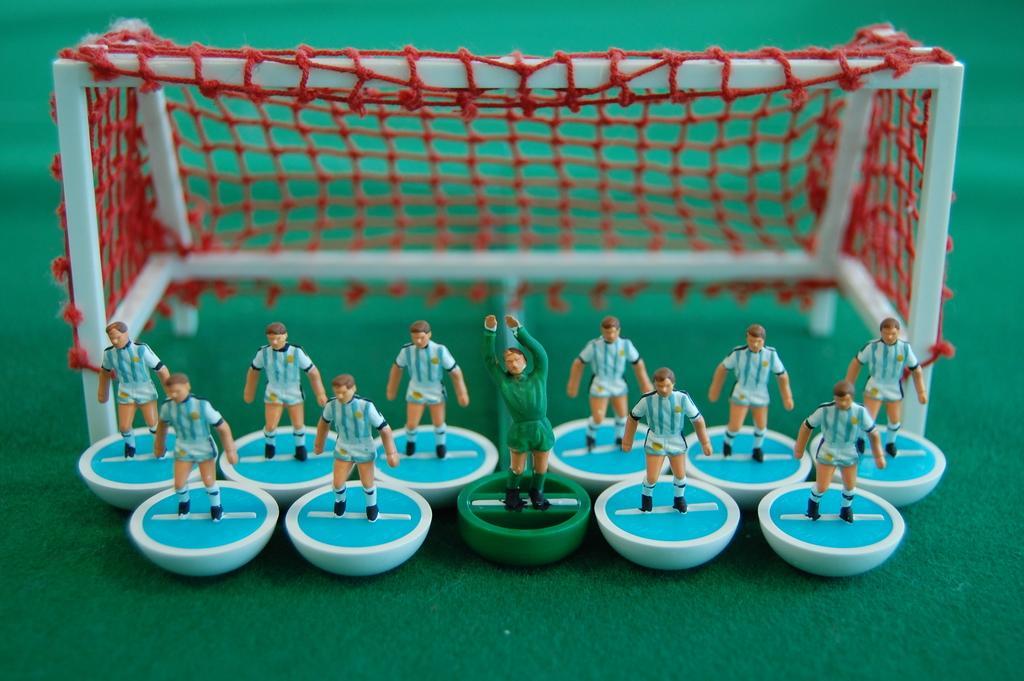Describe this image in one or two sentences. In this image there are miniatures of football players and a goal post. 